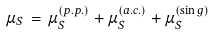Convert formula to latex. <formula><loc_0><loc_0><loc_500><loc_500>\mu _ { S } \, = \, \mu _ { S } ^ { ( p . p . ) } + \mu _ { S } ^ { ( a . c . ) } + \mu _ { S } ^ { ( \sin g ) }</formula> 